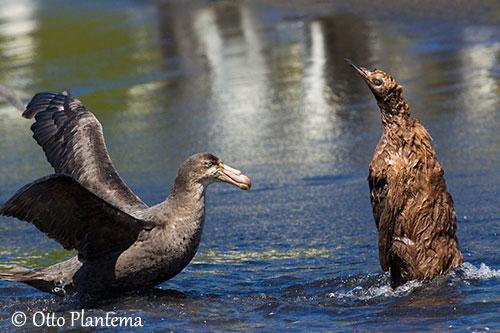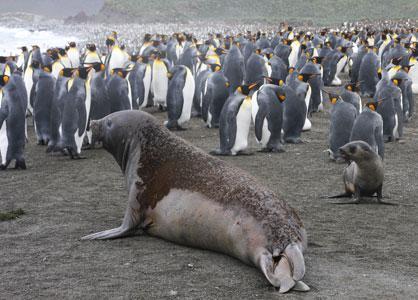The first image is the image on the left, the second image is the image on the right. Assess this claim about the two images: "A sea lion is shown in one of the images.". Correct or not? Answer yes or no. Yes. 